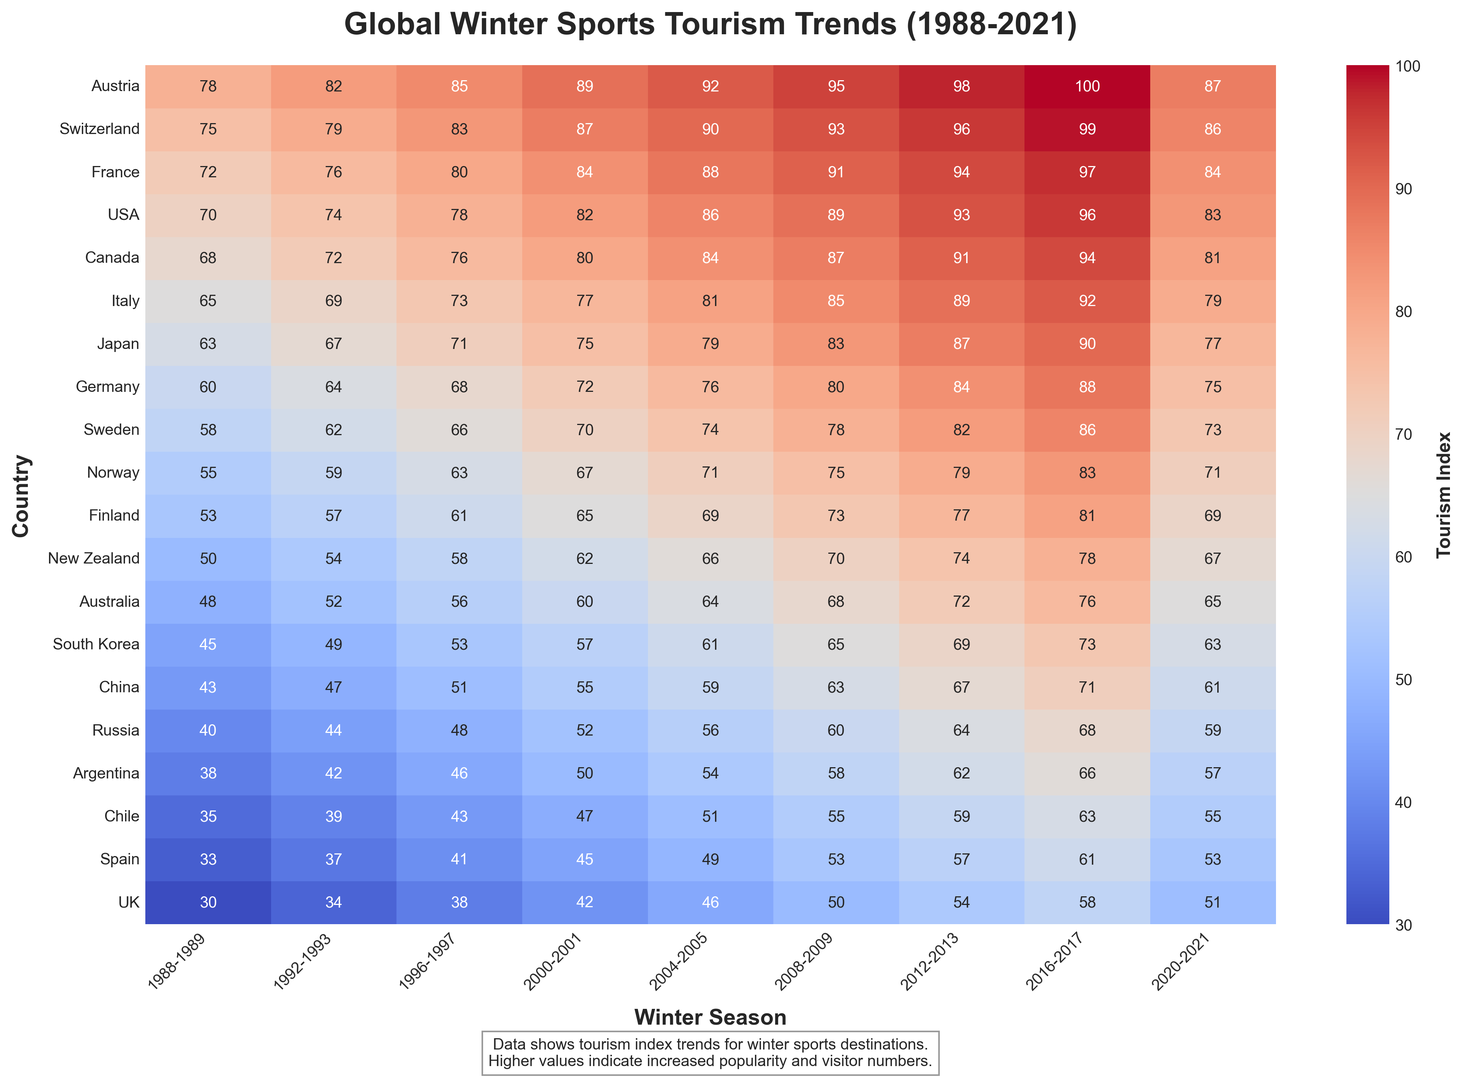What country has the highest tourism index in the 2020-2021 season? The heatmap shows the tourism index values by country and season. In the 2020-2021 season, Austria has the highest value of 87.
Answer: Austria Which two countries had the same tourism index in the 2016-2017 season and what was it? By scanning the values in the 2016-2017 column, Switzerland and France both have a tourism index of 99.
Answer: Switzerland and France, 99 Which country showed the greatest increase in tourism index from 1988-1989 to 2020-2021? Calculate the difference for each country between 1988-1989 and 2020-2021. Austria increased by (87-78)=9, Switzerland by (86-75)=11, and similarly for other countries. Norway showed an increase from 55 to 83, which is the greatest increase of 28 points.
Answer: Norway Which season showed the highest overall tourism index across all countries combined? Sum the tourism index values for each season across all countries and compare the totals. For example, 2016-2017 has values (100+99+97+96+94+92+90+88+86+83+81+78+76+73+71+68+66+63+61+58). Summing these gives the highest combined value.
Answer: 2016-2017 By how much did the tourism index for Japan increase from 1988-1989 to 2016-2017? Subtract the value for Japan in 1988-1989 from the value in 2016-2017: 90 - 63 = 27.
Answer: 27 Which country had the lowest tourism index in any given season, and what was that value? Look for the smallest value in the entire heatmap. The smallest value is 30 for the UK in the 1988-1989 season.
Answer: UK, 30 How does the tourism index for Canada in 2012-2013 compare to that in 1988-1989? Subtract the value of 1988-1989 (68) from 2012-2013 (91): 91 - 68 = 23.
Answer: 23 (increase) What is the average tourism index for Finland across all seasons? Sum the values for Finland across all seasons and divide by the number of seasons. (53+57+61+65+69+73+77+81+69) / 9 = 67.
Answer: 67 Between New Zealand and Australia, which country had a higher tourism index in the 2004-2005 season? Compare the values for New Zealand (66) and Australia (64) in 2004-2005; 66 is greater than 64.
Answer: New Zealand What is the median tourism index value for Germany across the seasons? Arrange the values for Germany in ascending order: (60, 64, 68, 72, 76, 80, 84, 88, 75). The median value is the middle one, which is 76.
Answer: 76 